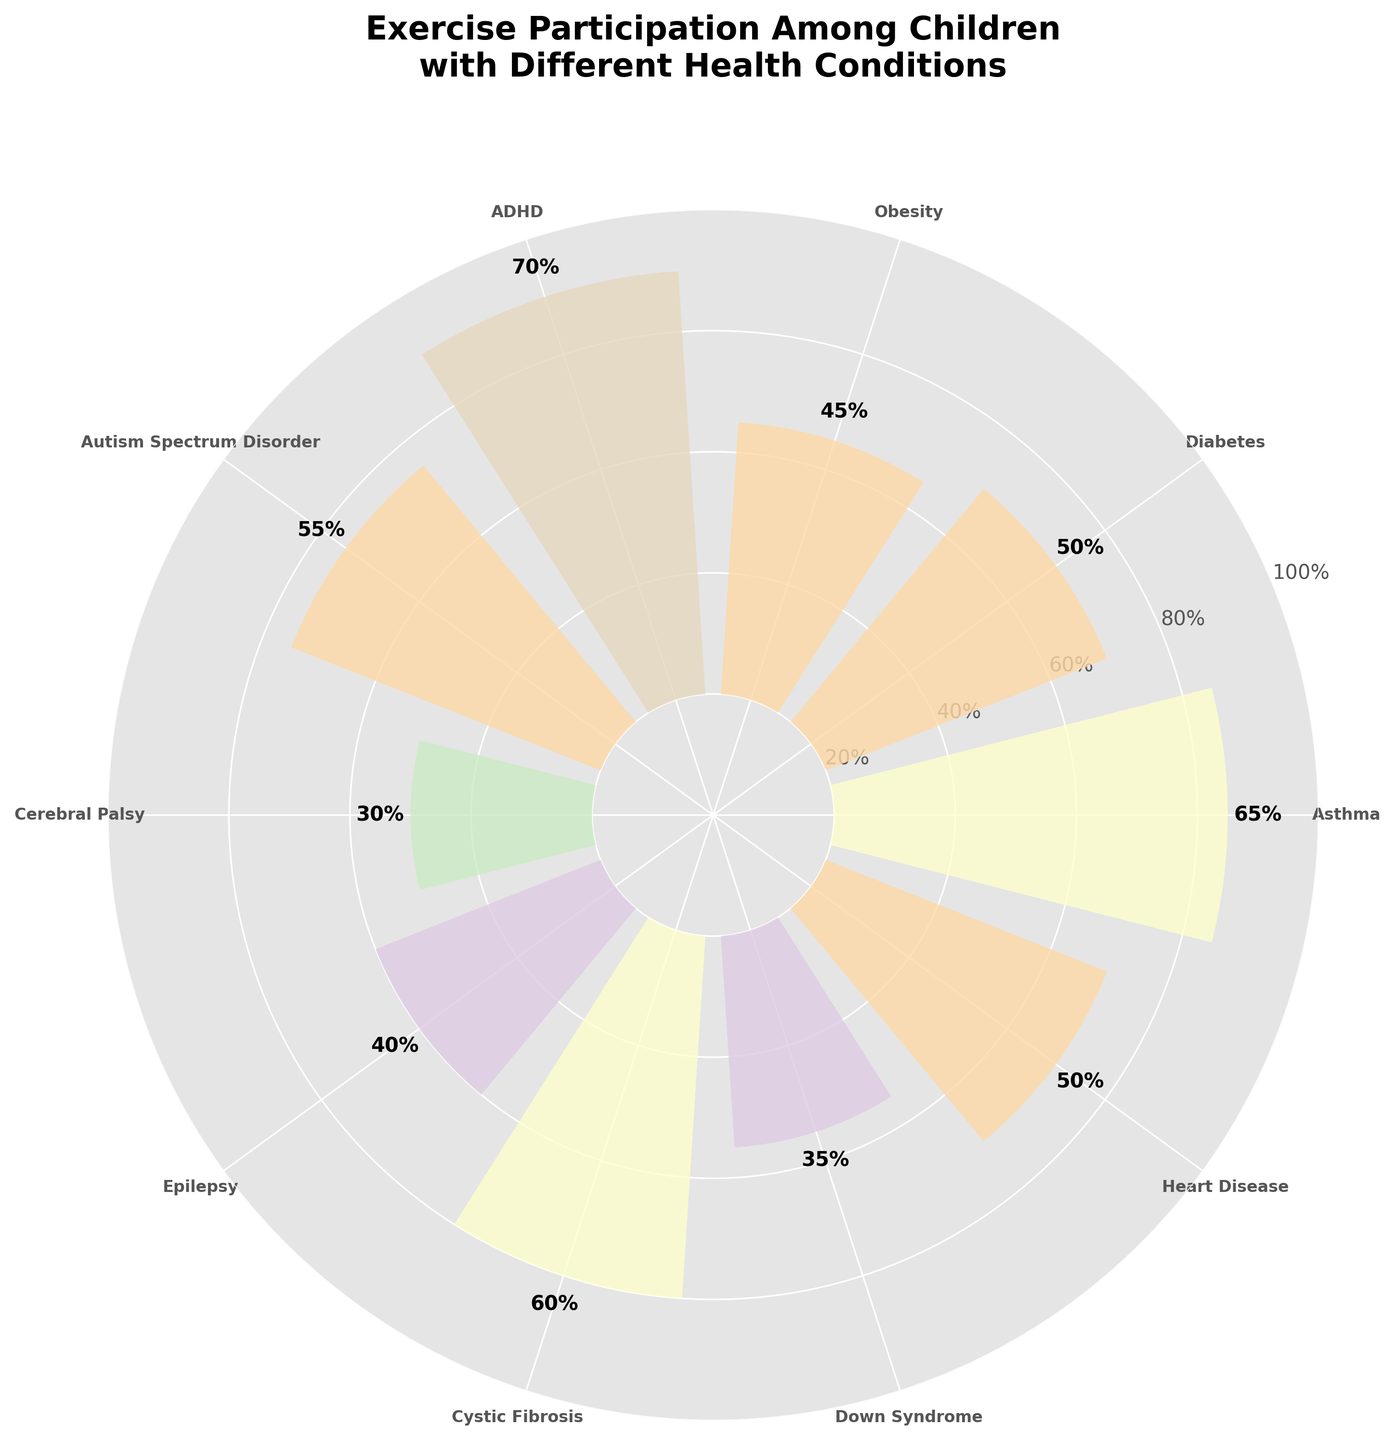What is the title of the chart? The title is located at the top of the chart and is usually displayed in a larger font than the other text on the chart.
Answer: Exercise Participation Among Children with Different Health Conditions What is the proportion of exercise participation for children with Asthma? To find the proportion for a specific condition, locate the corresponding label on the chart and read the value. The percentage is also labeled above the bar in the rose chart.
Answer: 65% Which condition has the lowest proportion of exercise participation? First, identify and compare all the proportions displayed on the chart. The condition with the lowest numerical value is the answer.
Answer: Cerebral Palsy How many health conditions have a proportion of exercise participation above 50%? Count the number of conditions where the labeled proportion exceeds 50%.
Answer: 5 conditions What is the difference in exercise participation proportion between children with Autism Spectrum Disorder and children with Epilepsy? Locate and subtract the proportion for Epilepsy from the proportion for Autism Spectrum Disorder. Autism Spectrum Disorder: 55%, Epilepsy: 40%, so the difference is 55% - 40%.
Answer: 15% Which condition has a higher proportion of exercise participation: Down Syndrome or Heart Disease? Compare the proportions for Down Syndrome and Heart Disease by locating their values on the chart.
Answer: Heart Disease What is the average proportion of exercise participation among children with ADHD, Autism Spectrum Disorder, and Cystic Fibrosis? To find the average, add the proportions for ADHD (70%), Autism Spectrum Disorder (55%), and Cystic Fibrosis (60%), then divide by 3. (70 + 55 + 60) / 3 = 61.67%.
Answer: 61.67% How many conditions have a proportion of exercise participation between 30% and 60%? Identify and count the number of conditions where the proportion falls within the range of 30% to 60%.
Answer: 5 conditions Which condition has a higher proportion of exercise participation: Obesity or Diabetes? Compare the proportions for Obesity and Diabetes by locating their values on the chart.
Answer: Diabetes 